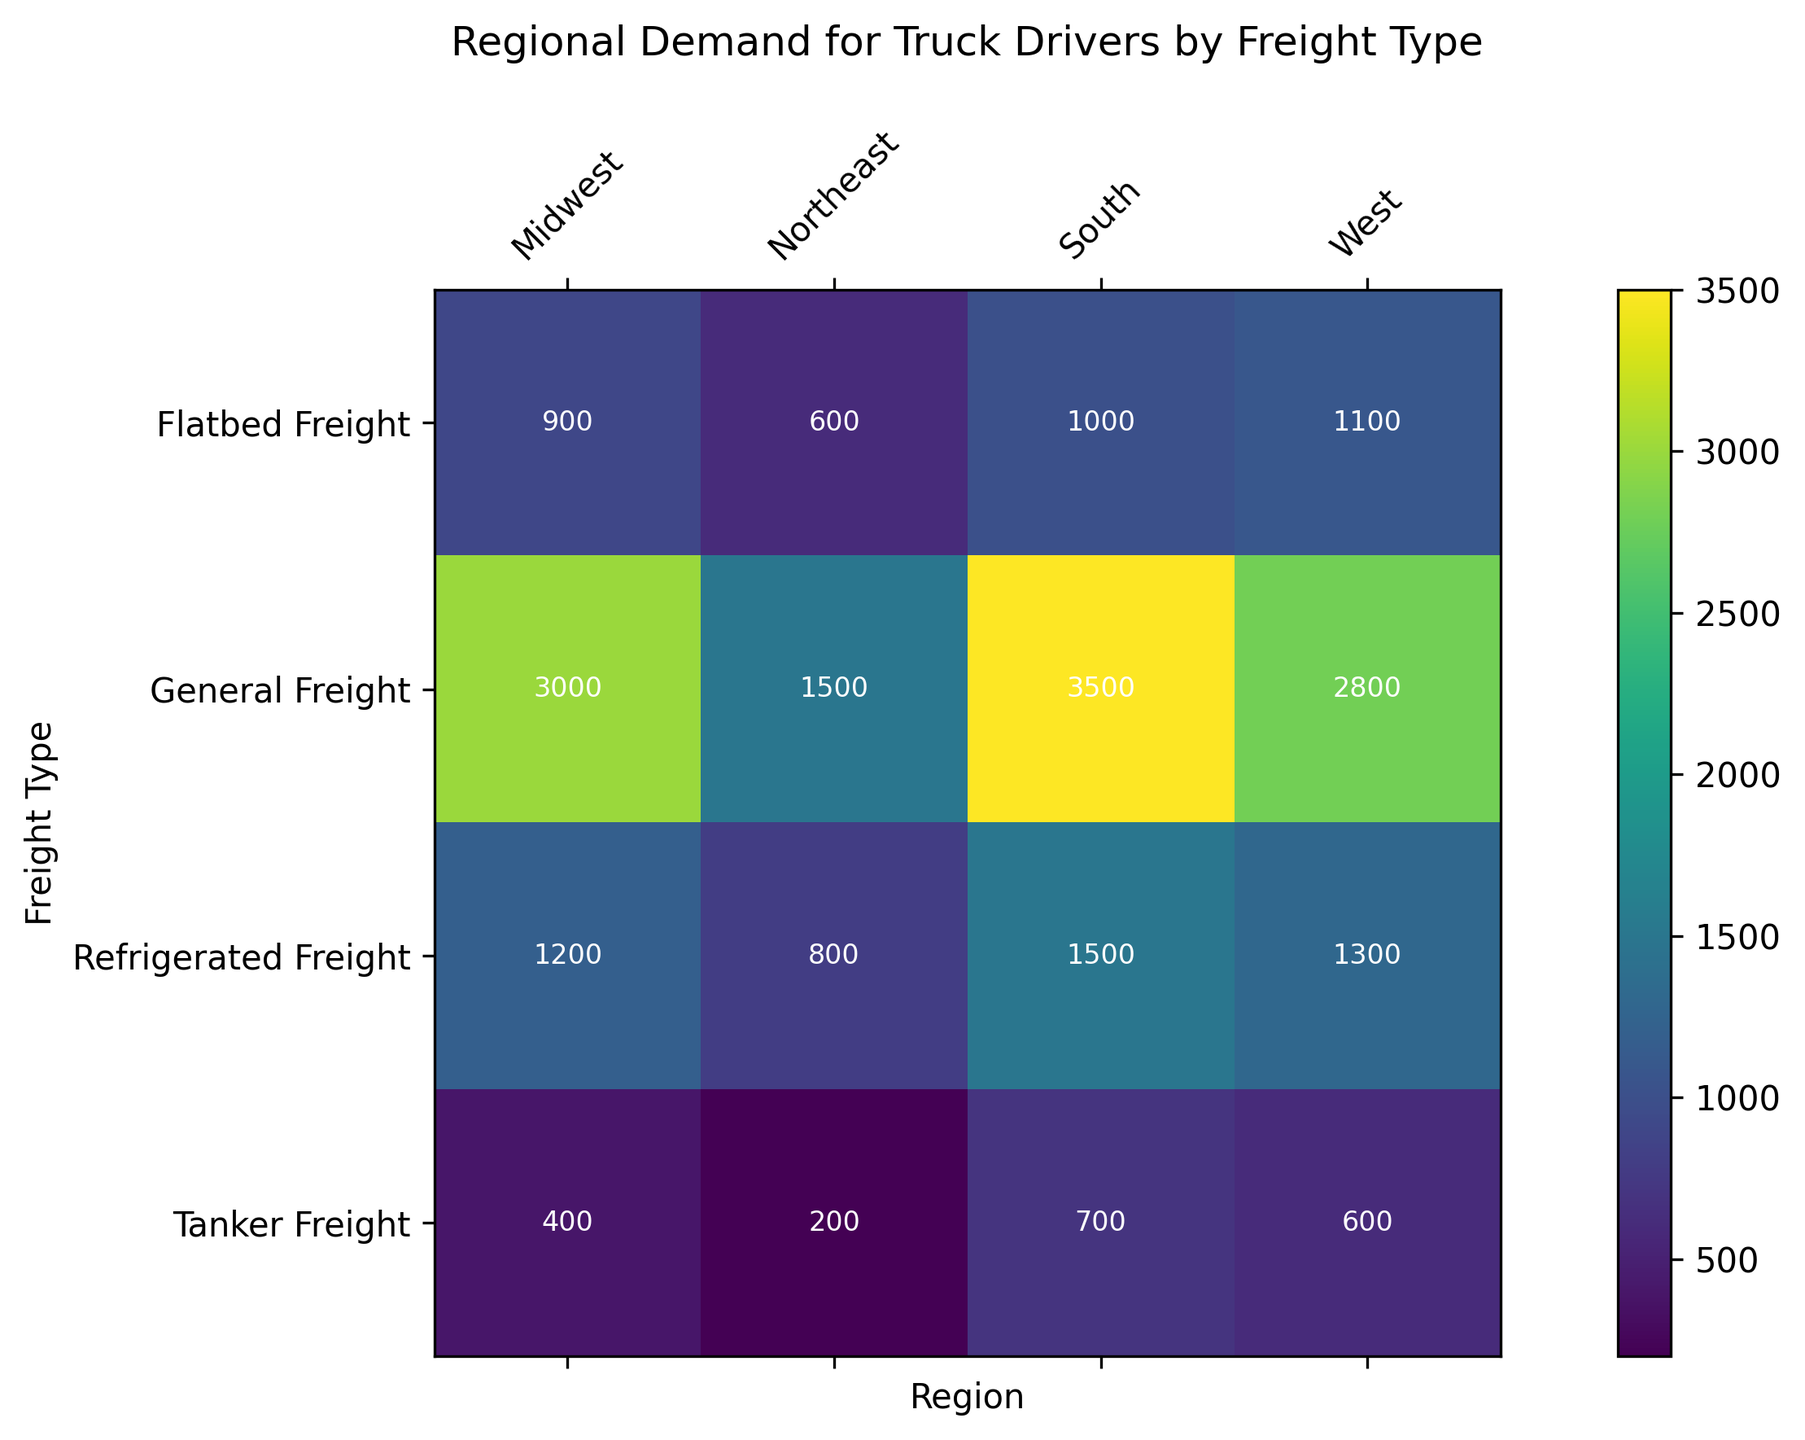What's the region with the highest demand for General Freight? Look at the 'General Freight' row and compare the values for each region. The highest value is 3500 in the 'South' column.
Answer: South Which region has the lowest demand for Tanker Freight? Look at the 'Tanker Freight' row and compare the values for each region. The lowest value is 200 in the 'Northeast' column.
Answer: Northeast Which freight type has the overall highest demand in the West? In the 'West' column, compare the values for each freight type. The highest value is 2800 for 'General Freight'.
Answer: General Freight Is the demand for Refrigerated Freight in the South greater than the demand for General Freight in the Northeast? In the figure, the demand for Refrigerated Freight in the South is 1500 and the demand for General Freight in the Northeast is 1500. Since both are equal, the answer is no.
Answer: No What is the total demand for all freight types in the Northeast? Sum up the demand values for all freight types in the Northeast: 1500 (General Freight) + 800 (Refrigerated Freight) + 600 (Flatbed Freight) + 200 (Tanker Freight) = 3100.
Answer: 3100 Compare the demand for Flatbed Freight between the Midwest and the West. Which one is higher? In the 'Flatbed Freight' row, compare the values for the Midwest (900) and the West (1100). The West has a higher demand.
Answer: West 